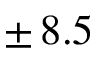<formula> <loc_0><loc_0><loc_500><loc_500>\pm \, 8 . 5</formula> 